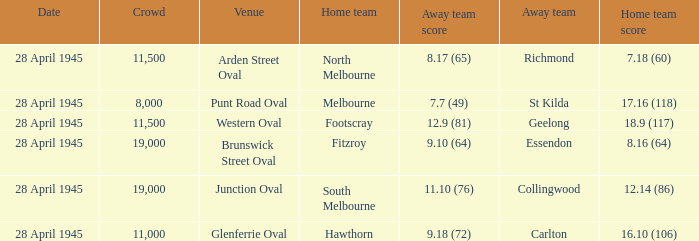What home team has an Away team of richmond? North Melbourne. 